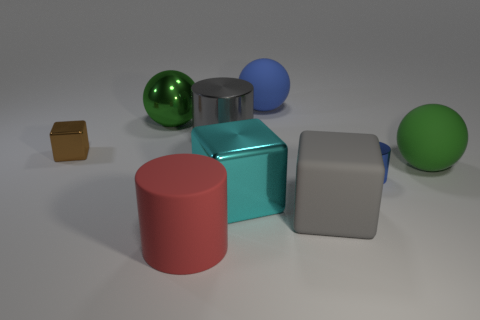There is a gray shiny thing; what number of brown blocks are in front of it?
Ensure brevity in your answer.  1. Is the material of the big blue ball the same as the green ball that is left of the big blue sphere?
Ensure brevity in your answer.  No. Do the gray block and the small cylinder have the same material?
Your response must be concise. No. There is a tiny blue shiny thing on the right side of the brown metallic thing; is there a rubber object that is to the right of it?
Keep it short and to the point. Yes. What number of matte balls are in front of the small shiny block and behind the brown shiny object?
Keep it short and to the point. 0. What shape is the green thing that is left of the cyan metal thing?
Offer a very short reply. Sphere. How many other cyan shiny objects are the same size as the cyan object?
Give a very brief answer. 0. Do the rubber object that is right of the large rubber block and the shiny sphere have the same color?
Your answer should be very brief. Yes. What is the sphere that is left of the blue metal cylinder and in front of the big blue thing made of?
Provide a short and direct response. Metal. Is the number of green metallic spheres greater than the number of tiny red metal things?
Keep it short and to the point. Yes. 